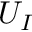Convert formula to latex. <formula><loc_0><loc_0><loc_500><loc_500>U _ { I }</formula> 